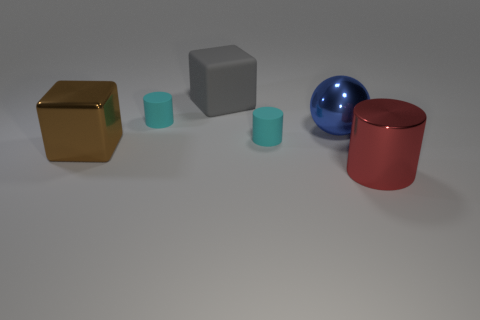What could be the purpose of arranging these objects in this way? This arrangement might be intended to showcase different geometric shapes and materials for educational purposes or for a visual demonstration. It could also be part of a composition in a photography studio to test lighting effects on different surfaces or a 3D render practicing object placement and rendering techniques. 